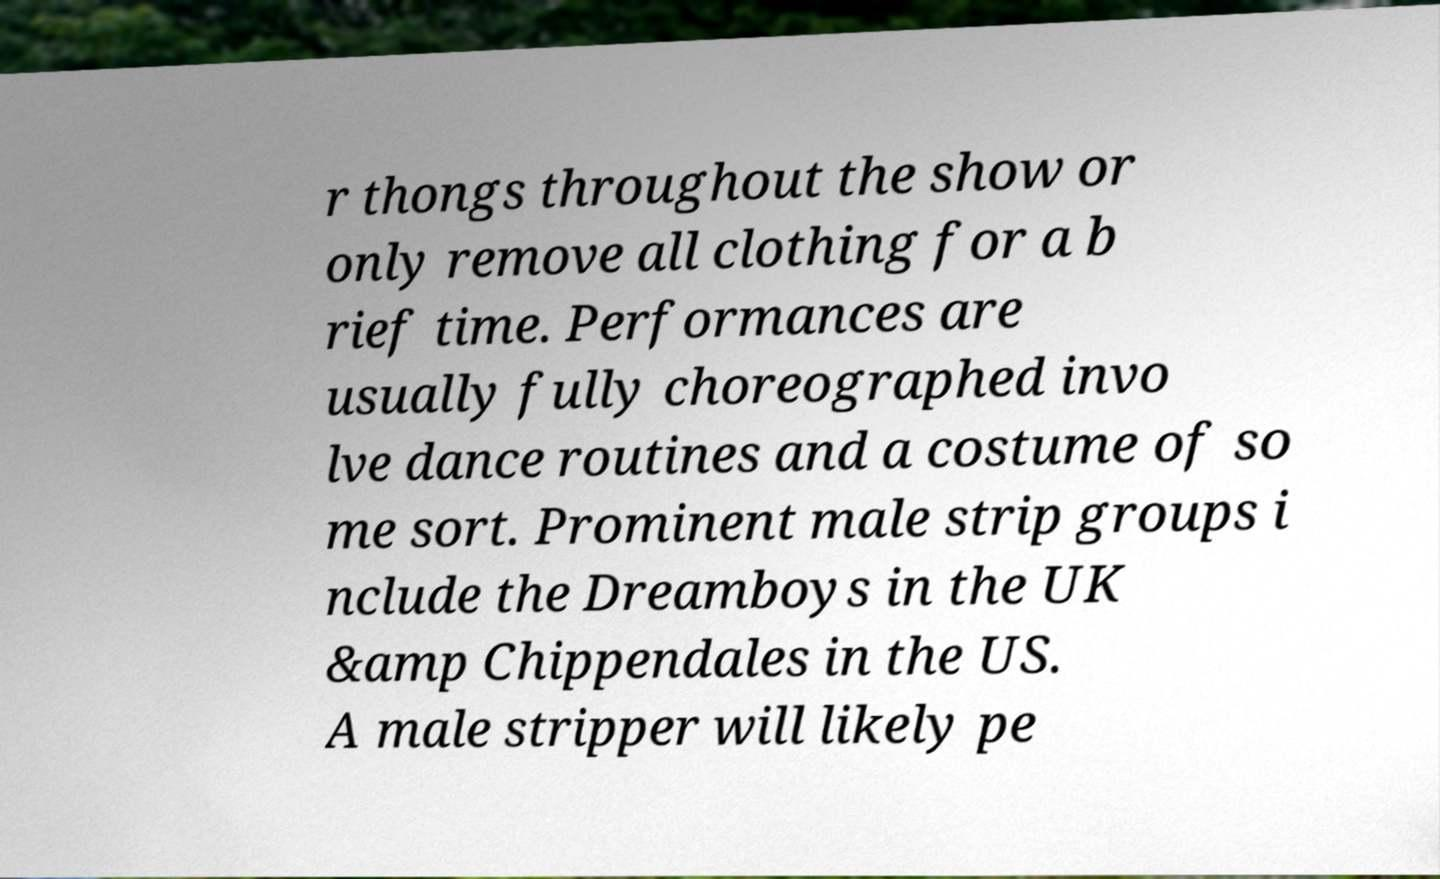For documentation purposes, I need the text within this image transcribed. Could you provide that? r thongs throughout the show or only remove all clothing for a b rief time. Performances are usually fully choreographed invo lve dance routines and a costume of so me sort. Prominent male strip groups i nclude the Dreamboys in the UK &amp Chippendales in the US. A male stripper will likely pe 